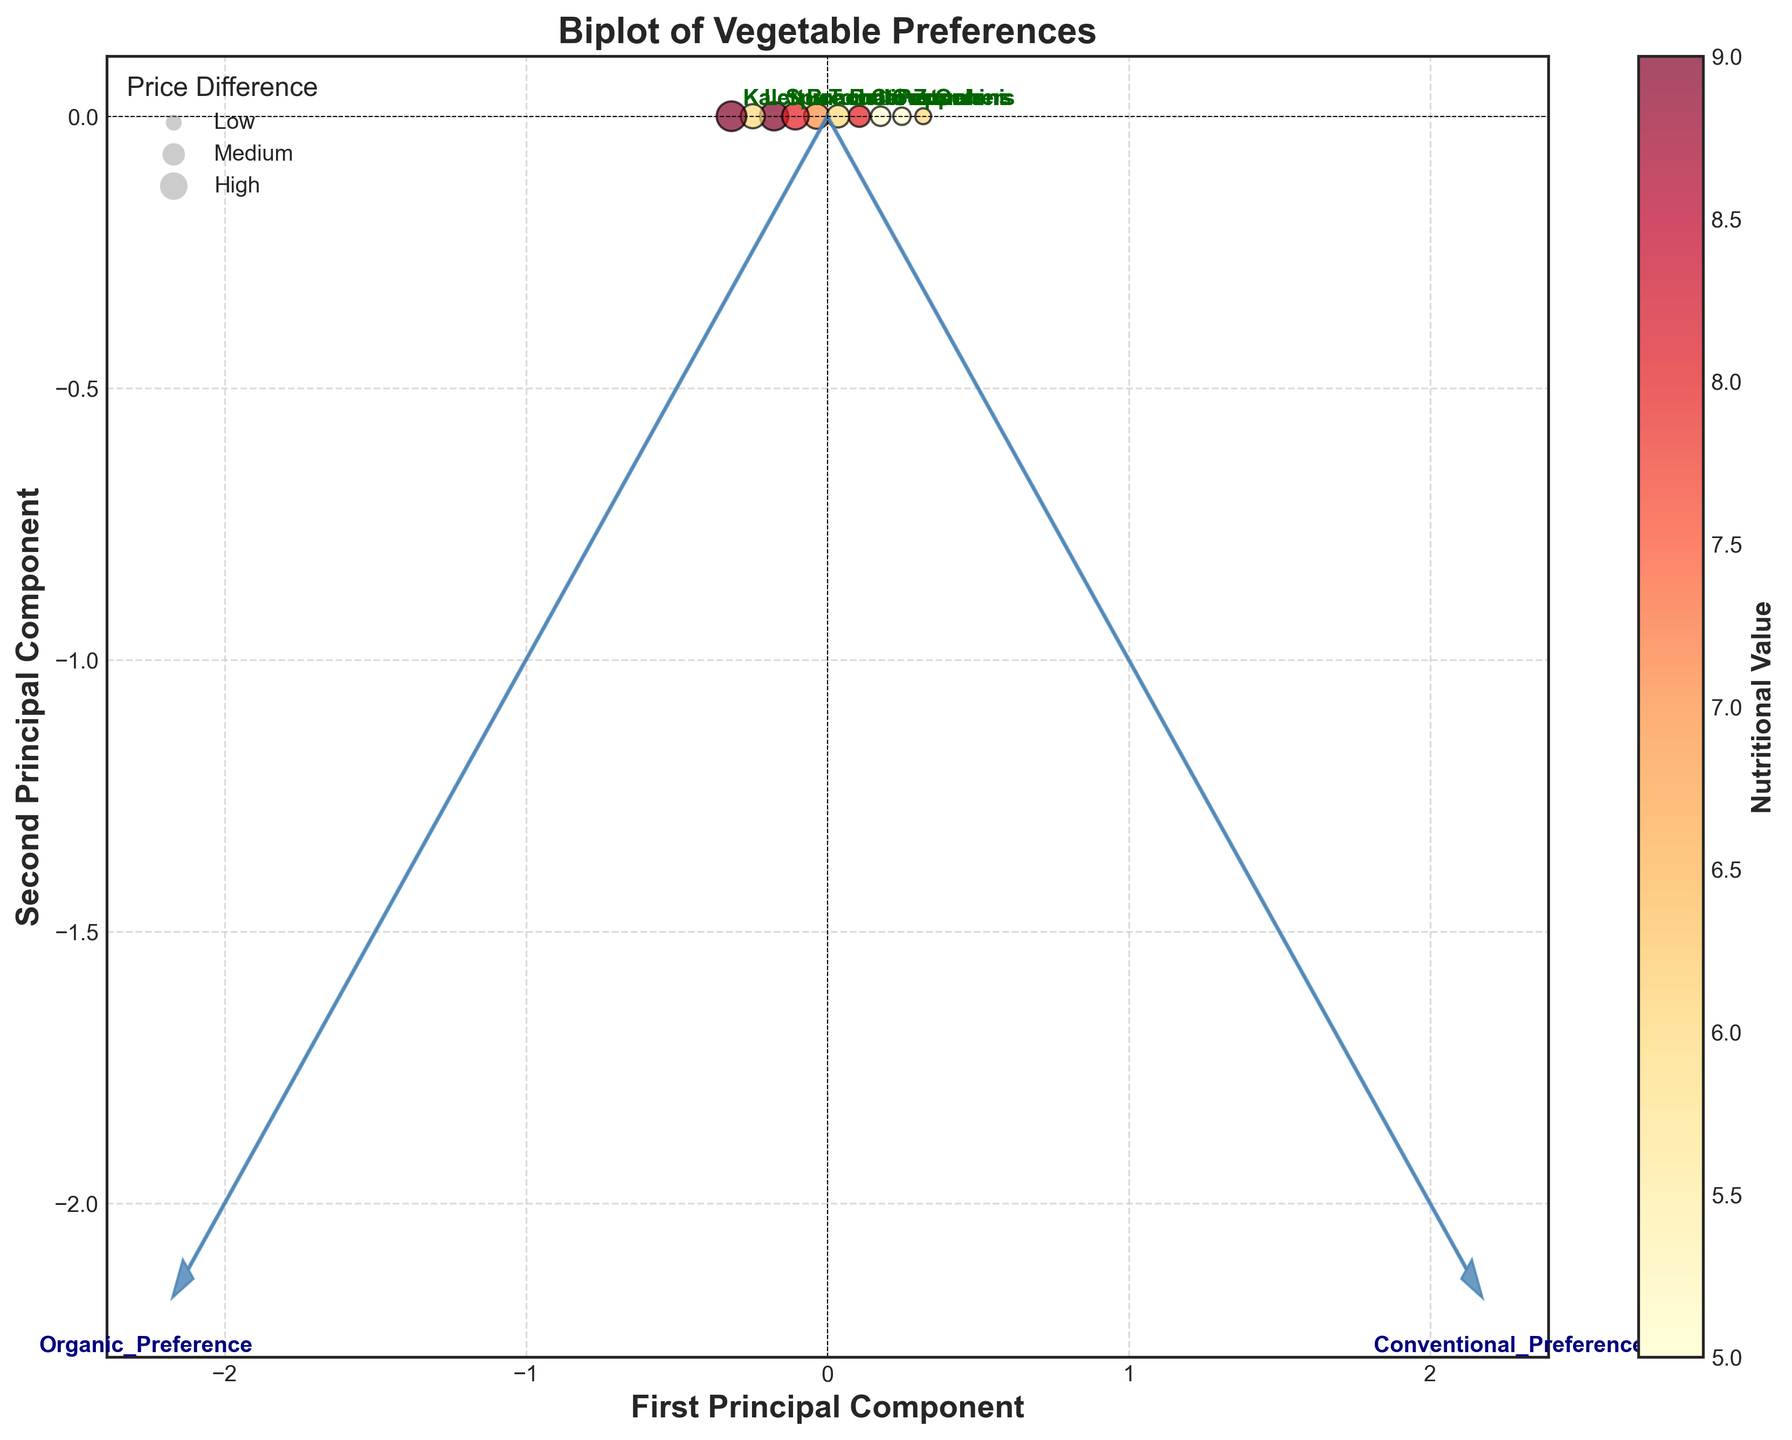What's the title of the figure? The title of the figure is normally found at the top of the plot. For this figure, it's "Biplot of Vegetable Preferences".
Answer: Biplot of Vegetable Preferences How many vegetables are plotted in the figure? To determine the number of vegetables, count the labeled data points in the figure. Each label corresponds to a vegetable. From the data, there are 10 vegetables: Tomatoes, Carrots, Spinach, Bell Peppers, Broccoli, Cucumbers, Lettuce, Zucchini, Kale, and Onions.
Answer: 10 Which vegetable shows the highest preference for organic produce? By looking at the positions of the data points and their annotations, the point farthest along the vector for "Organic_Preference" indicates the highest preference for organic produce. Kale is farthest along this vector.
Answer: Kale Which vegetable has the highest nutritional value? Each data point is color-coded by its nutritional value. By comparing the colors to the color bar, the vegetable plotted with the darkest red color represents the highest nutritional value. From the data, Kale and Spinach both have the highest nutritional value of 9.
Answer: Kale and Spinach What does the size of the bubbles represent in the plot? The size of the bubbles is indicated by the legend for bubble size. It labels "Price Difference" with different sizes representing low, medium, and high price differences.
Answer: Price Difference Which vegetables have near-equal preferences for organic vs. conventional produce? Points closest to the origin (0,0) or along the line representing equal preference for both organic and conventional produce will indicate near-equal preferences. Cucumbers and Zucchini are plotted closely along this line.
Answer: Cucumbers and Zucchini Compare the price differences for Lettuce and Onions. Which one has a higher price difference? The bubble sizes denote price differences. Lettuce has a larger bubble compared to Onions, indicating a higher price difference.
Answer: Lettuce Is there a strong relationship between nutritional value and organic preference based on the plot? To evaluate this, observe the color gradient (indicating nutritional value) along the "Organic_Preference" vector. If the higher nutritional values (darker colors) trend towards higher organic preference, then a strong relationship is suggested. Vegetables like Kale, Spinach, and Broccoli, which have high nutritional values, are also high in organic preference, indicating some correlation.
Answer: Yes Which vegetable has the lowest preference for organic produce? The vegetable plotted farthest along the "Conventional_Preference" vector would have the lowest preference for organic. Onions have the lowest preference for organic produce as it is plotted farthest along the conventional preference vector.
Answer: Onions What do the arrows in the plot represent? In biplots, arrows represent the original variables before they were transformed into principal components. Here, the arrows indicate the directions of "Organic_Preference" and "Conventional_Preference".
Answer: Directions of preferences 